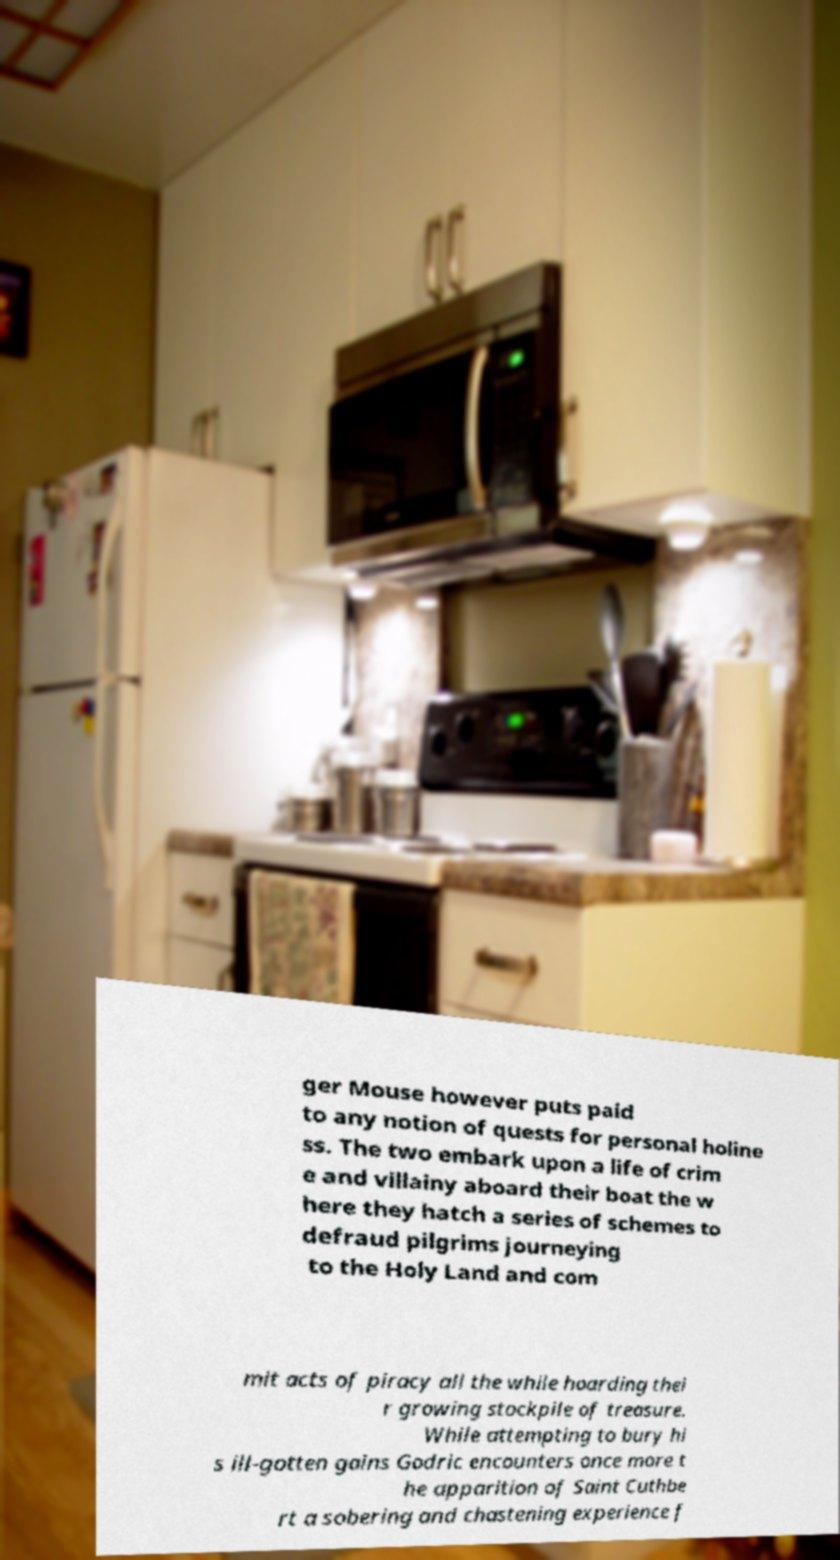Could you extract and type out the text from this image? ger Mouse however puts paid to any notion of quests for personal holine ss. The two embark upon a life of crim e and villainy aboard their boat the w here they hatch a series of schemes to defraud pilgrims journeying to the Holy Land and com mit acts of piracy all the while hoarding thei r growing stockpile of treasure. While attempting to bury hi s ill-gotten gains Godric encounters once more t he apparition of Saint Cuthbe rt a sobering and chastening experience f 